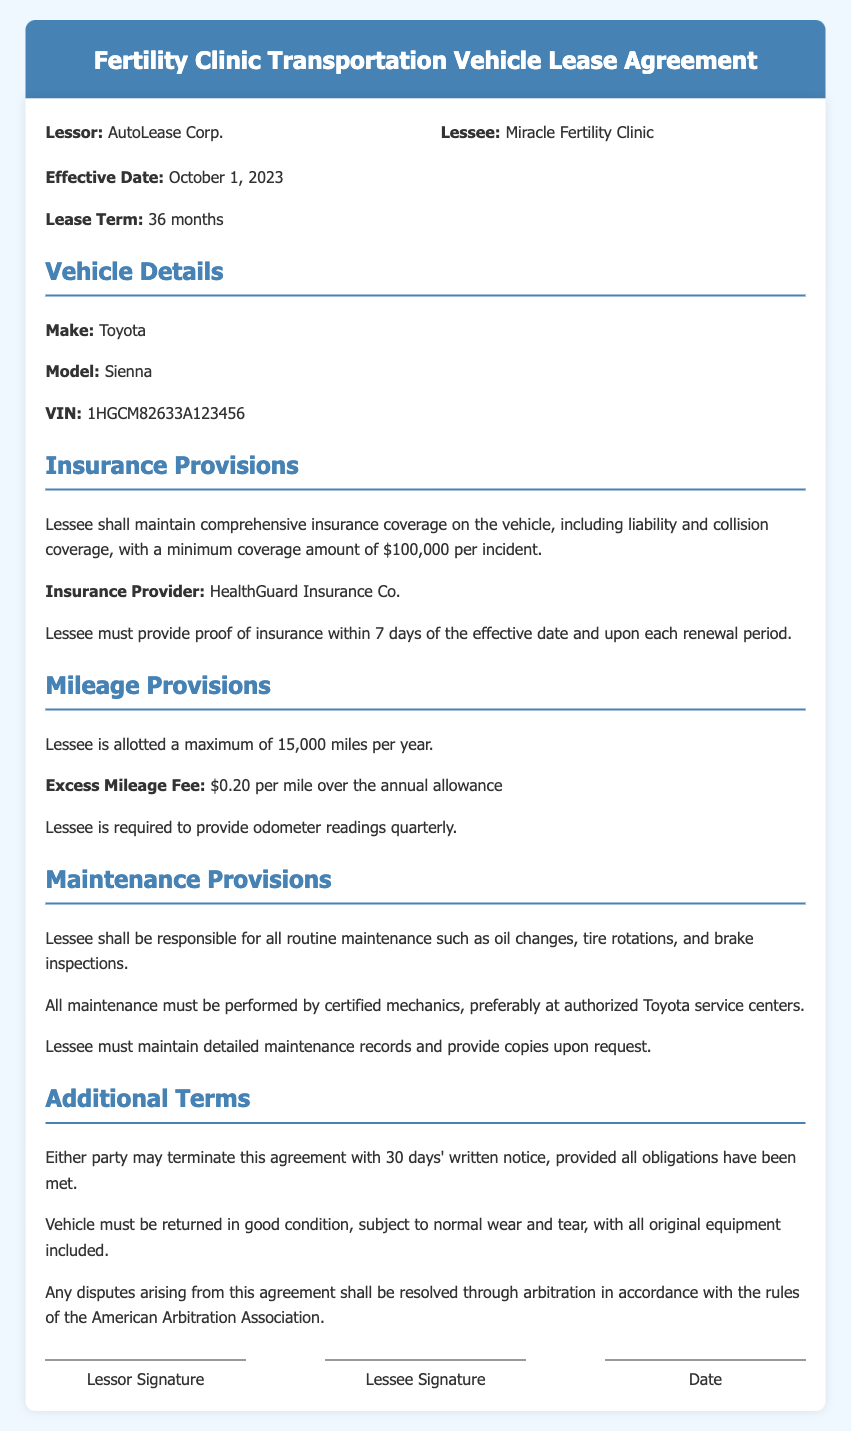What is the effective date of the lease agreement? The effective date is stated in the document under "Effective Date."
Answer: October 1, 2023 Who is the insurance provider mentioned in the agreement? The document specifies the insurance provider in the "Insurance Provisions" section.
Answer: HealthGuard Insurance Co What is the maximum mileage allotted per year to the lessee? The maximum mileage is mentioned in the "Mileage Provisions" section.
Answer: 15,000 miles What is the excess mileage fee per mile? The fee for excess mileage is listed in the "Mileage Provisions" section.
Answer: $0.20 Who is responsible for routine maintenance of the vehicle? The responsibility for maintenance is outlined in the "Maintenance Provisions" section.
Answer: Lessee What must the lessee provide within 7 days of the effective date? This requirement is outlined in the "Insurance Provisions" section of the document.
Answer: Proof of insurance What is the lease term duration? The duration of the lease term is mentioned early in the document.
Answer: 36 months What type of coverage must the lessee maintain on the vehicle? The type of coverage is specified in the "Insurance Provisions" section.
Answer: Comprehensive insurance coverage How long is the notice period to terminate the agreement? The notice period is stated in the "Additional Terms" section.
Answer: 30 days 